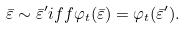<formula> <loc_0><loc_0><loc_500><loc_500>\bar { \varepsilon } \sim \bar { \varepsilon } ^ { \prime } i f f \varphi _ { t } ( \bar { \varepsilon } ) = \varphi _ { t } ( \bar { \varepsilon } ^ { \prime } ) .</formula> 